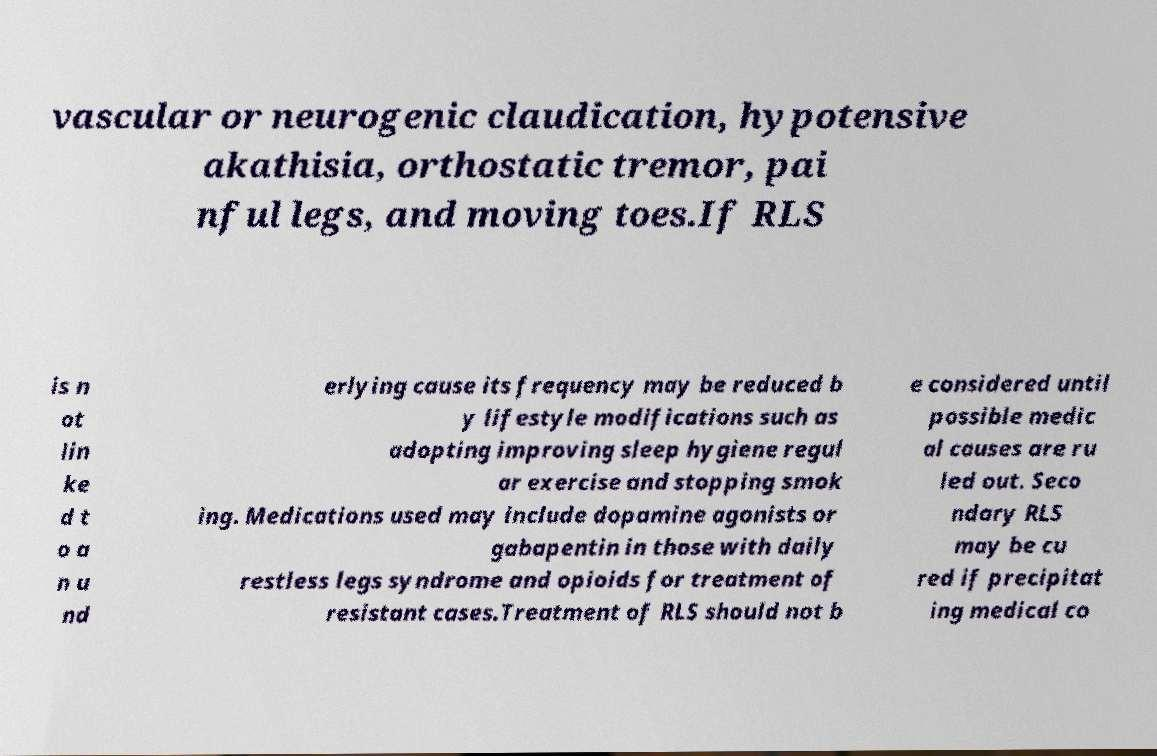Could you extract and type out the text from this image? vascular or neurogenic claudication, hypotensive akathisia, orthostatic tremor, pai nful legs, and moving toes.If RLS is n ot lin ke d t o a n u nd erlying cause its frequency may be reduced b y lifestyle modifications such as adopting improving sleep hygiene regul ar exercise and stopping smok ing. Medications used may include dopamine agonists or gabapentin in those with daily restless legs syndrome and opioids for treatment of resistant cases.Treatment of RLS should not b e considered until possible medic al causes are ru led out. Seco ndary RLS may be cu red if precipitat ing medical co 